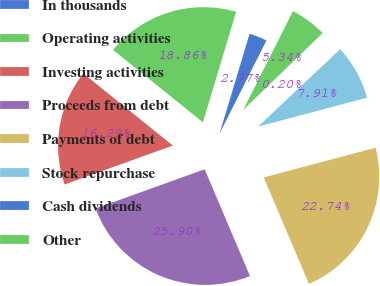<chart> <loc_0><loc_0><loc_500><loc_500><pie_chart><fcel>In thousands<fcel>Operating activities<fcel>Investing activities<fcel>Proceeds from debt<fcel>Payments of debt<fcel>Stock repurchase<fcel>Cash dividends<fcel>Other<nl><fcel>2.77%<fcel>18.86%<fcel>16.29%<fcel>25.9%<fcel>22.74%<fcel>7.91%<fcel>0.2%<fcel>5.34%<nl></chart> 